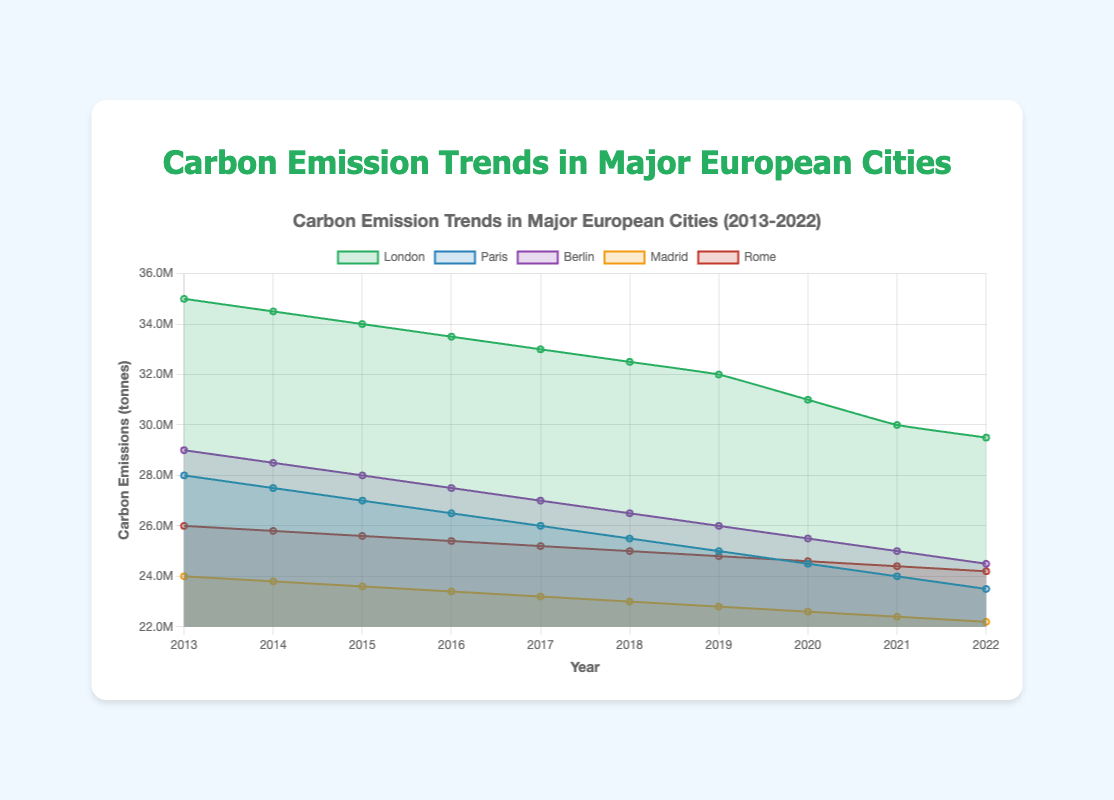What's the overall trend of carbon emissions in London from 2013 to 2022? The chart shows that the carbon emissions in London have been decreasing steadily year by year. Observing the plotted data points, the emissions drop from 35 million tonnes in 2013 to 29.5 million tonnes in 2022.
Answer: Decreasing Which city had the highest carbon emissions in 2022? To determine the highest carbon emissions in 2022, look at the end points of each city's line. The line for London is the highest in 2022 with around 29.5 million tonnes.
Answer: London Comparing 2014 emissions, which city saw a greater reduction in carbon emissions by 2022: Paris or Berlin? In 2014, Paris had 27.5 million tonnes, and in 2022, it had 23.5 million tonnes, a reduction of 4 million tonnes. Berlin had 28.5 million tonnes in 2014 and 24.5 million tonnes in 2022, a reduction of 4 million tonnes as well. Therefore, both cities saw the same reduction.
Answer: Both saw the same reduction What is the average carbon emission for Madrid from 2013 to 2022? The data for Madrid's carbon emissions from 2013 to 2022 is: [24, 23.8, 23.6, 23.4, 23.2, 23, 22.8, 22.6, 22.4, 22.2 (all in million tonnes)]. Sum them up: 24 + 23.8 + 23.6 + 23.4 + 23.2 + 23 + 22.8 + 22.6 + 22.4 + 22.2 = 230, then divide by 10 years: 230/10 = 23 million tonnes.
Answer: 23 million tonnes What color represents the trend line for Berlin, and what was its emission level in 2016? In the chart, Berlin is represented by a line of purple color, and the emission level for Berlin in 2016 was 27.5 million tonnes as seen directly on the line corresponding to Berlin.
Answer: Purple, 27.5 million tonnes By what percentage did Rome's carbon emissions decrease from 2013 to 2022? The carbon emissions in Rome in 2013 were 26 million tonnes and in 2022 were 24.2 million tonnes. First, find the difference: 26 - 24.2 = 1.8 million tonnes. Then calculate the percentage decrease: (1.8 / 26) * 100% = 6.92%.
Answer: 6.92% Between 2017 and 2020, which city experienced the steepest decline in carbon emissions, and what was the amount of decrease? Measure the slopes of the lines between 2017 and 2020. London decreased from 33 million to 31 million tonnes, a drop of 2 million tonnes. Paris from 26 million to 24.5 million tonnes, a drop of 1.5 million tonnes. Berlin from 27 million to 25.5 million tonnes, a drop of 1.5 million tonnes. Madrid from 23.2 million to 22.6 million tonnes, a drop of 0.6 million tonnes. Rome from 25.2 million to 24.6 million tonnes, a drop of 0.6 million tonnes. London had the steepest decline with a decrease of 2 million tonnes.
Answer: London, 2 million tonnes From the chart, in which year did Paris and Berlin have the same carbon emissions, and what was the amount? Identify the year where the lines for Paris and Berlin intersect. This occurs in 2021. Both cities had carbon emissions of 24 million tonnes in that year.
Answer: 2021, 24 million tonnes 